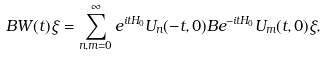Convert formula to latex. <formula><loc_0><loc_0><loc_500><loc_500>B W ( t ) \xi = \sum _ { n , m = 0 } ^ { \infty } e ^ { i t H _ { 0 } } U _ { n } ( - t , 0 ) B e ^ { - i t H _ { 0 } } U _ { m } ( t , 0 ) \xi ,</formula> 